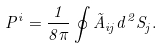<formula> <loc_0><loc_0><loc_500><loc_500>P ^ { i } = \frac { 1 } { 8 \pi } \oint \tilde { A } _ { i j } d ^ { 2 } S _ { j } .</formula> 